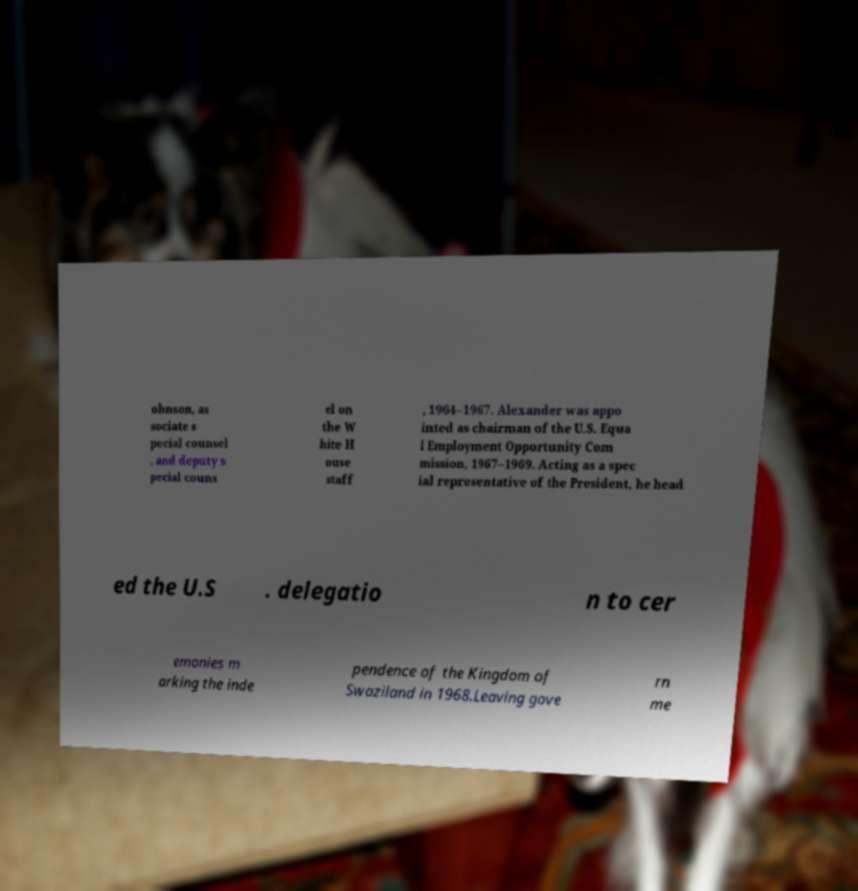Please read and relay the text visible in this image. What does it say? ohnson, as sociate s pecial counsel , and deputy s pecial couns el on the W hite H ouse staff , 1964–1967. Alexander was appo inted as chairman of the U.S. Equa l Employment Opportunity Com mission, 1967–1969. Acting as a spec ial representative of the President, he head ed the U.S . delegatio n to cer emonies m arking the inde pendence of the Kingdom of Swaziland in 1968.Leaving gove rn me 